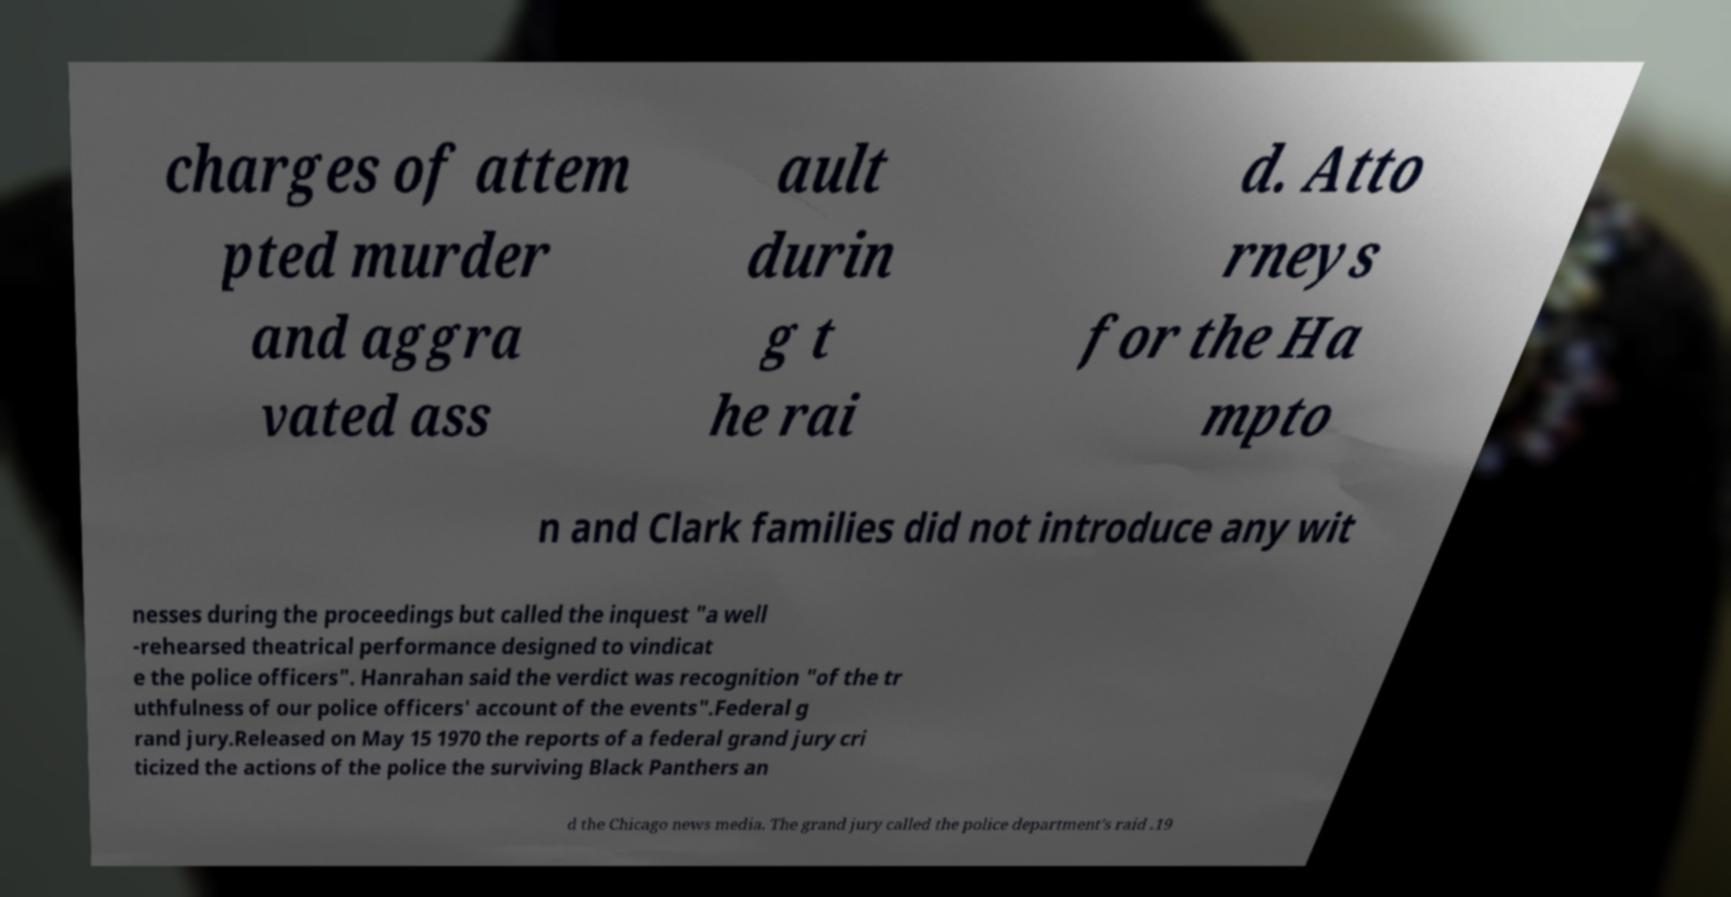Could you extract and type out the text from this image? charges of attem pted murder and aggra vated ass ault durin g t he rai d. Atto rneys for the Ha mpto n and Clark families did not introduce any wit nesses during the proceedings but called the inquest "a well -rehearsed theatrical performance designed to vindicat e the police officers". Hanrahan said the verdict was recognition "of the tr uthfulness of our police officers' account of the events".Federal g rand jury.Released on May 15 1970 the reports of a federal grand jury cri ticized the actions of the police the surviving Black Panthers an d the Chicago news media. The grand jury called the police department's raid .19 